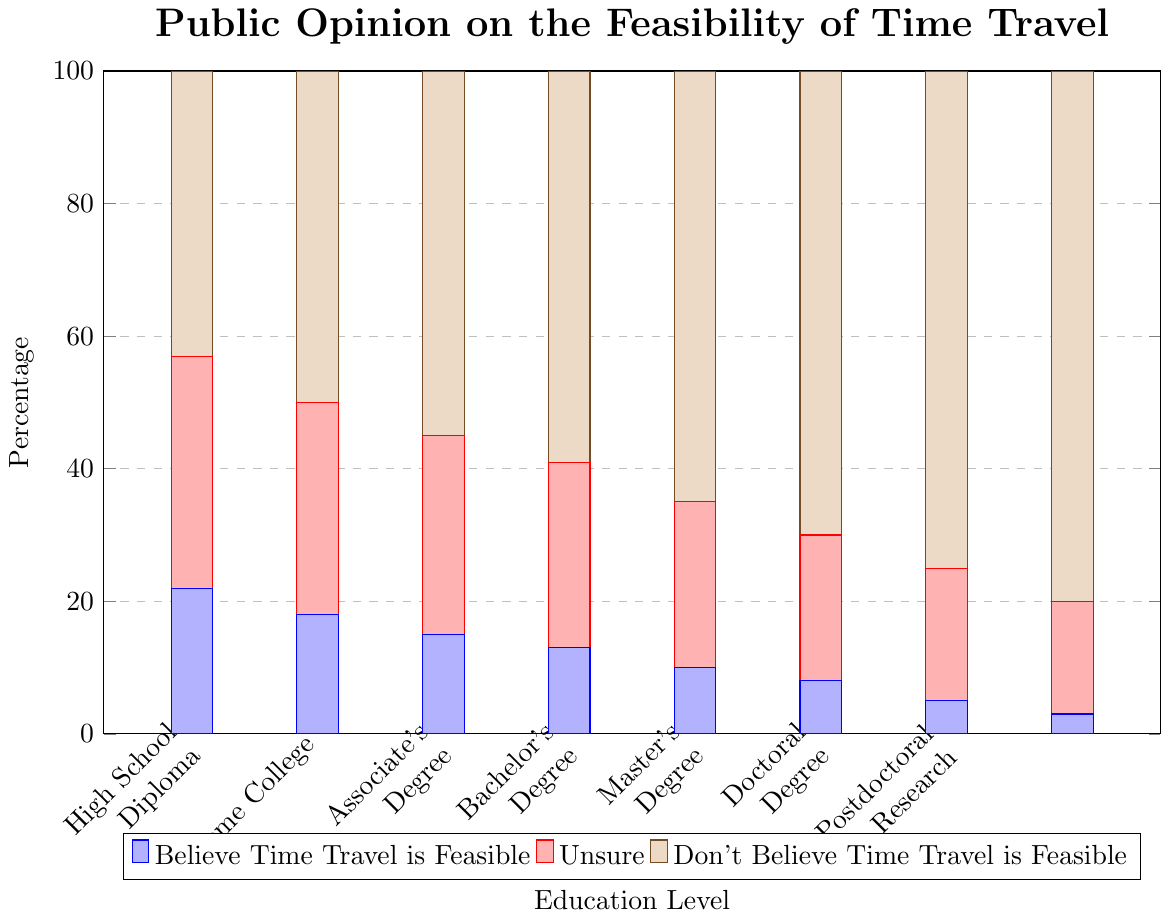What percentage of people with a high school diploma believe that time travel is feasible? According to the chart, look for the percentage indicated in the "Believe Time Travel is Feasible" category for those with a high school diploma.
Answer: 18% How many more people with a postdoctoral research degree don't believe in the feasibility of time travel compared to those with an associate's degree? Find the values for the "Don't Believe Time Travel is Feasible" category for both the postdoctoral research and associate's degree, then subtract the associate's degree percentage from the postdoctoral research percentage (80% - 59%).
Answer: 21% What is the combined percentage of individuals without a high school diploma who are either unsure or don't believe in time travel feasibility? Add the "Unsure" and "Don't Believe Time Travel is Feasible" percentages for the No High School Diploma group (35% + 43%).
Answer: 78% Which education level has the highest percentage of individuals who are unsure about the feasibility of time travel? Locate the highest percentage in the "Unsure" category across all education levels. The highest bar in the green section represents individuals without a high school diploma.
Answer: No High School Diploma Compare the belief in time travel feasibility between individuals with a bachelor's degree and a doctorate degree. Who is more skeptical of time travel feasibility? Examine the "Don't Believe Time Travel is Feasible" percentages for Bachelor's Degree and Doctoral Degree (65% and 75%, respectively). The higher percentage indicates greater skepticism.
Answer: Doctoral Degree What is the median percentage of people who "Don't Believe Time Travel is Feasible" across all education levels depicted in the chart? Arrange the percentages for "Don't Believe Time Travel is Feasible" in ascending order: 43%, 50%, 55%, 59%, 65%, 70%, 75%, 80%. The median is the average of the 4th and 5th values ((59% + 65%) / 2).
Answer: 62% Identify the education level that has the smallest percentage of individuals believing in the feasibility of time travel. Locate the smallest bar in the blue section of the chart. The smallest bar corresponds to postdoctoral research.
Answer: Postdoctoral Research What is the difference in percentage points between those who believe in time travel feasibility and those who are unsure at the master's degree level? Subtract the "Unsure" percentage from the "Believe Time Travel is Feasible" percentage for the Master's Degree level (22% - 8%).
Answer: 14% How many education levels have more than 30% of individuals unsure about the feasibility of time travel? Count the number of education levels where the "Unsure" category is greater than 30%. In this case, it applies only to No High School Diploma and High School Diploma.
Answer: 2 